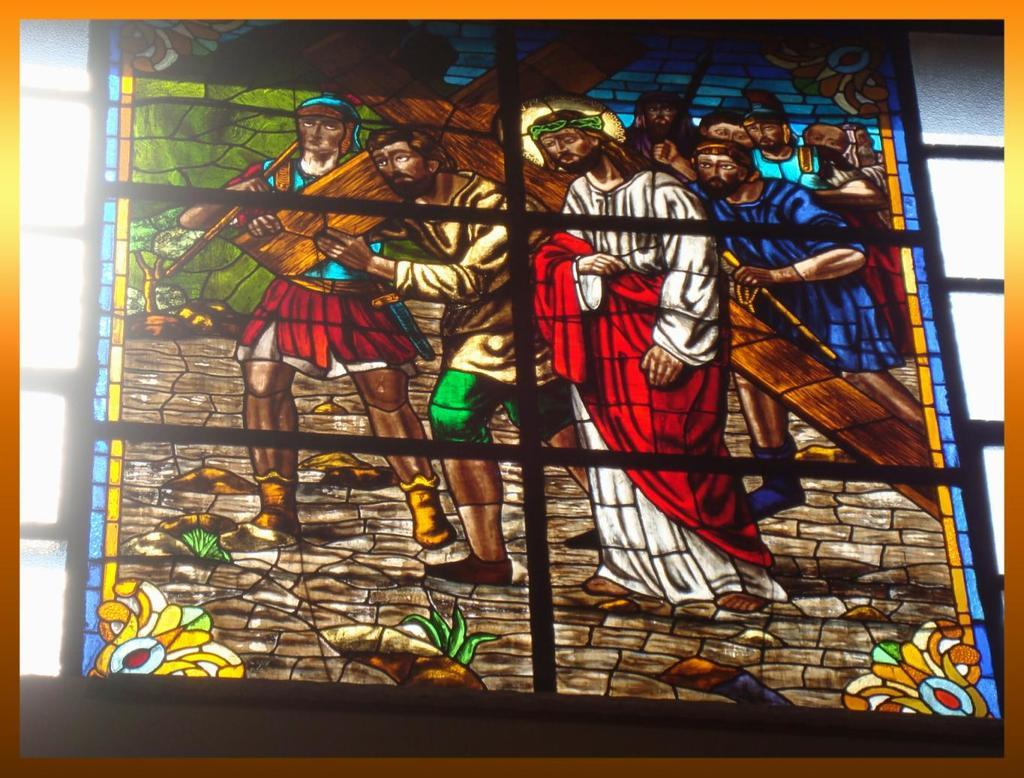What is the main object in the image? There is a frame in the image. What is depicted within the frame? The drawing in the frame depicts persons. How many clocks can be seen in the wilderness depicted in the drawing? There is no wilderness or clocks depicted in the drawing; it only shows persons. 